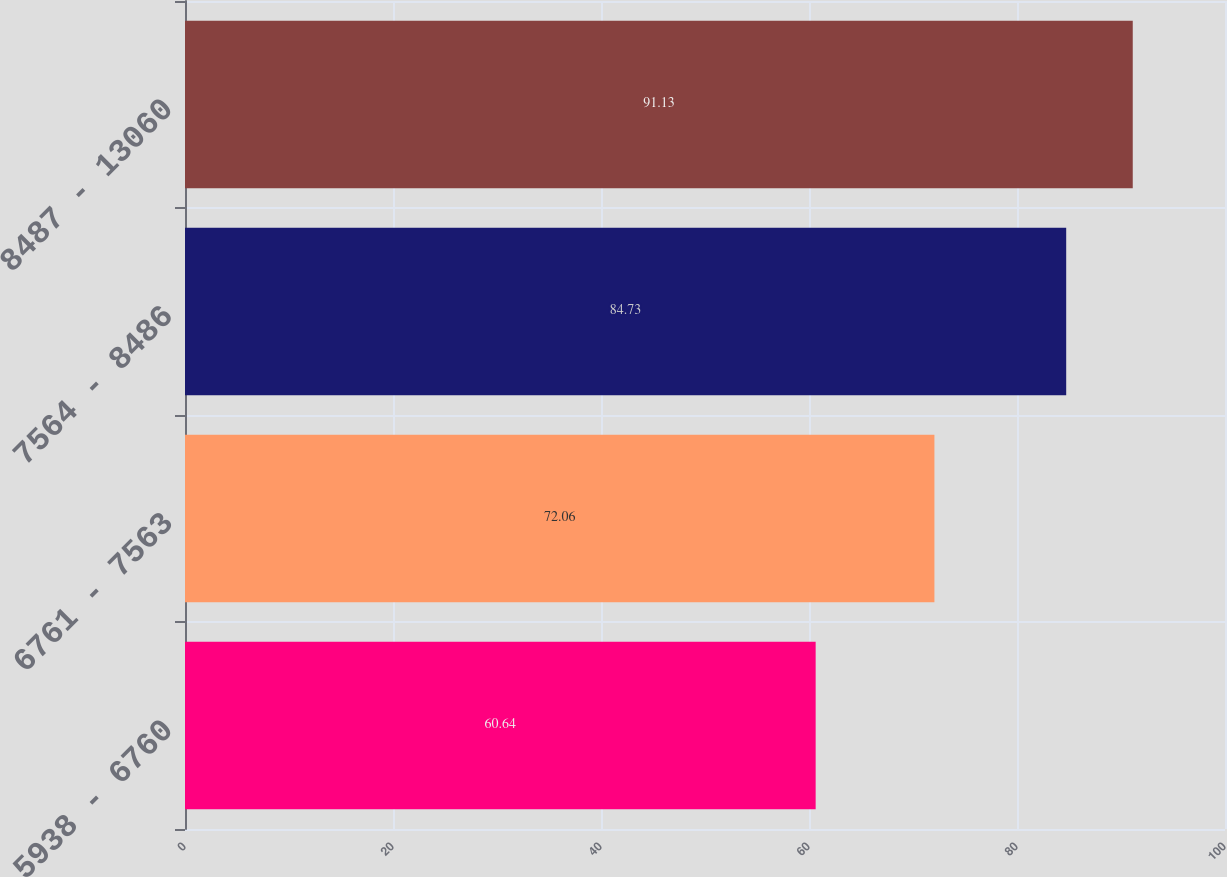Convert chart. <chart><loc_0><loc_0><loc_500><loc_500><bar_chart><fcel>5938 - 6760<fcel>6761 - 7563<fcel>7564 - 8486<fcel>8487 - 13060<nl><fcel>60.64<fcel>72.06<fcel>84.73<fcel>91.13<nl></chart> 